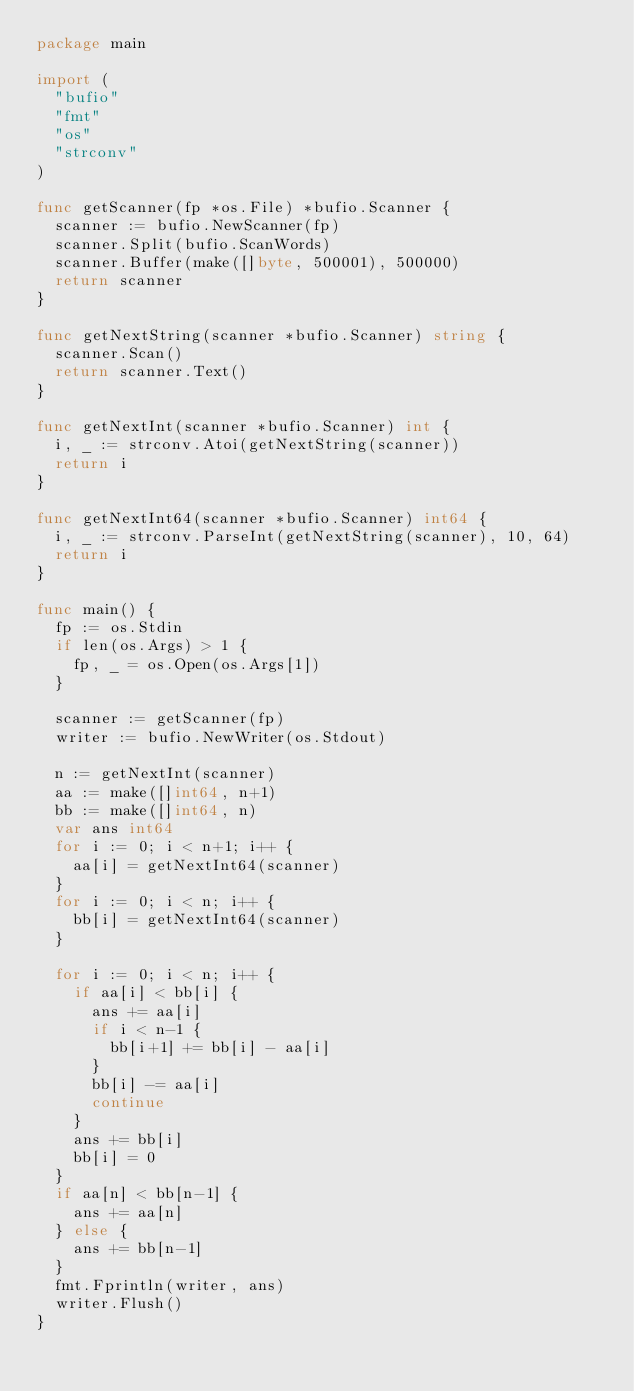<code> <loc_0><loc_0><loc_500><loc_500><_Go_>package main

import (
	"bufio"
	"fmt"
	"os"
	"strconv"
)

func getScanner(fp *os.File) *bufio.Scanner {
	scanner := bufio.NewScanner(fp)
	scanner.Split(bufio.ScanWords)
	scanner.Buffer(make([]byte, 500001), 500000)
	return scanner
}

func getNextString(scanner *bufio.Scanner) string {
	scanner.Scan()
	return scanner.Text()
}

func getNextInt(scanner *bufio.Scanner) int {
	i, _ := strconv.Atoi(getNextString(scanner))
	return i
}

func getNextInt64(scanner *bufio.Scanner) int64 {
	i, _ := strconv.ParseInt(getNextString(scanner), 10, 64)
	return i
}

func main() {
	fp := os.Stdin
	if len(os.Args) > 1 {
		fp, _ = os.Open(os.Args[1])
	}

	scanner := getScanner(fp)
	writer := bufio.NewWriter(os.Stdout)

	n := getNextInt(scanner)
	aa := make([]int64, n+1)
	bb := make([]int64, n)
	var ans int64
	for i := 0; i < n+1; i++ {
		aa[i] = getNextInt64(scanner)
	}
	for i := 0; i < n; i++ {
		bb[i] = getNextInt64(scanner)
	}

	for i := 0; i < n; i++ {
		if aa[i] < bb[i] {
			ans += aa[i]
			if i < n-1 {
				bb[i+1] += bb[i] - aa[i]
			}
			bb[i] -= aa[i]
			continue
		}
		ans += bb[i]
		bb[i] = 0
	}
	if aa[n] < bb[n-1] {
		ans += aa[n]
	} else {
		ans += bb[n-1]
	}
	fmt.Fprintln(writer, ans)
	writer.Flush()
}
</code> 